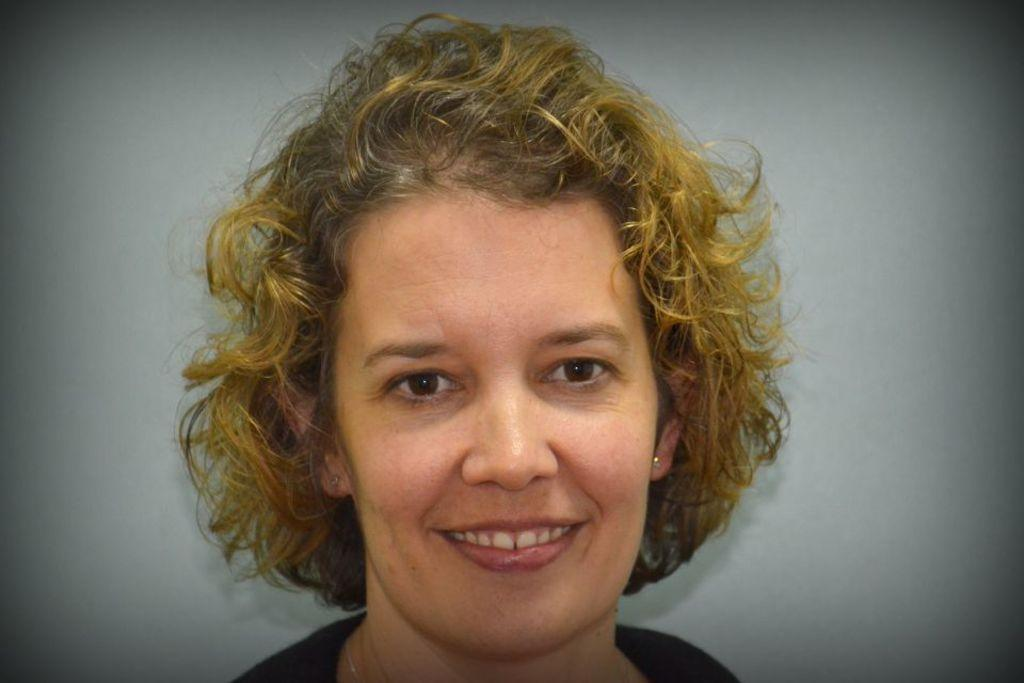Who is present in the image? There is a woman in the image. What is the woman's facial expression? The woman is smiling. What color is the background wall in the image? The background wall is painted white. What type of cabbage is the woman holding in the image? There is no cabbage present in the image; the woman is not holding any object. 